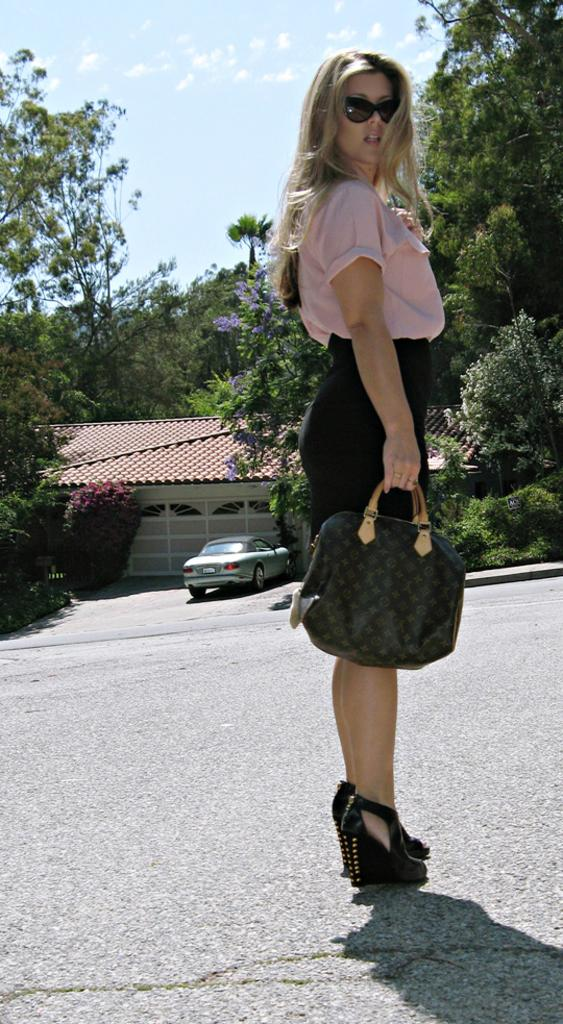What is the woman in the image holding? The woman is holding a handbag. What can be seen in the background of the image? There are clouds, trees, a house, a plant, and a car visible in the background of the image. What is the condition of the sky in the image? The sky is visible in the background of the image, and there are clouds present. What type of stamp can be seen on the woman's handbag in the image? There is no stamp visible on the woman's handbag in the image. What is the woman doing in the image that causes her to laugh? The woman is not laughing in the image, and there is no indication of her laughing or doing any specific activity. 